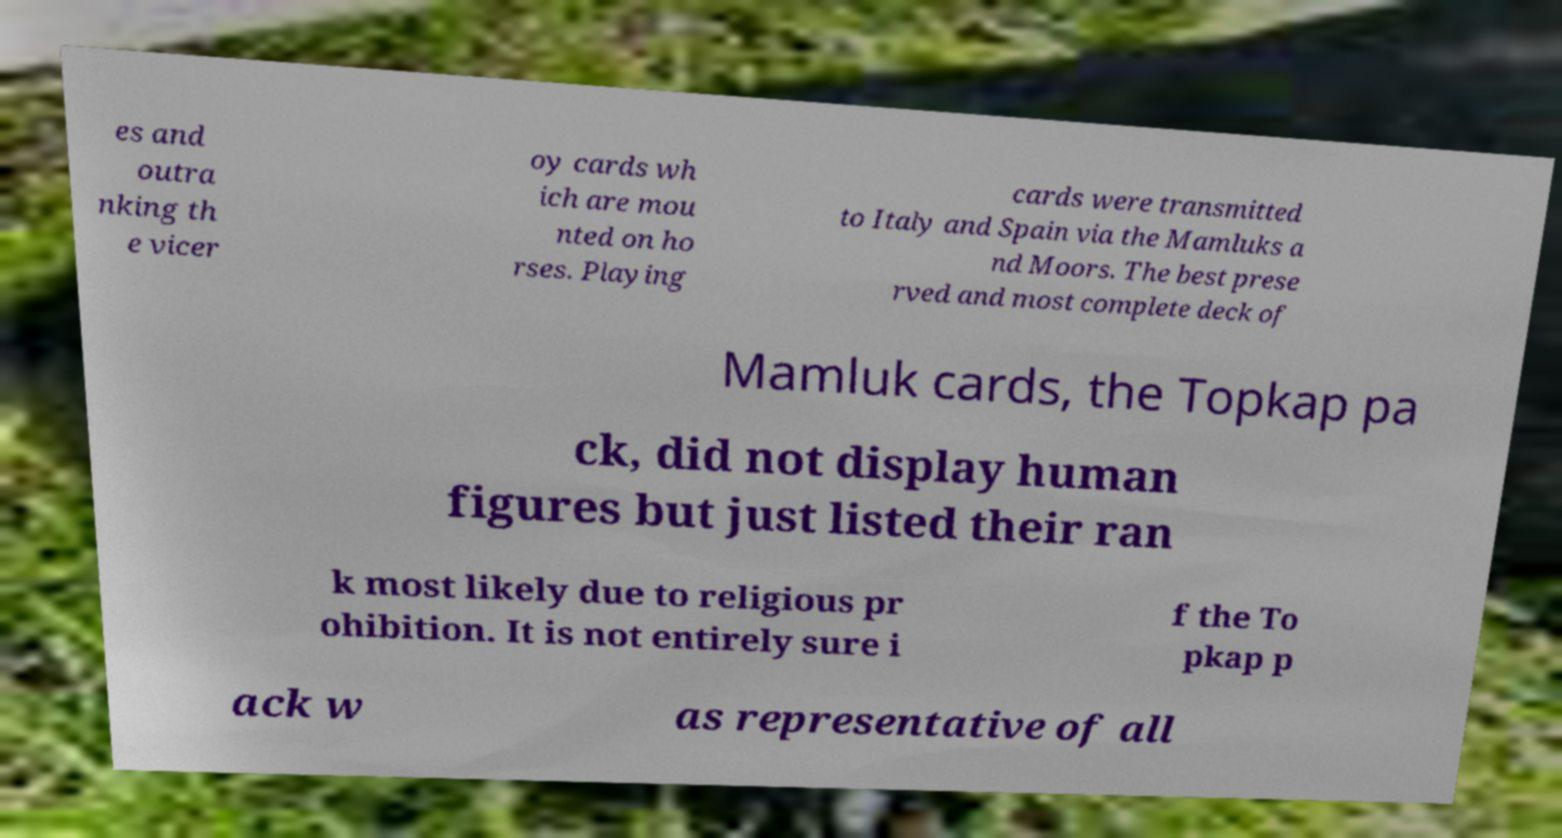Could you assist in decoding the text presented in this image and type it out clearly? es and outra nking th e vicer oy cards wh ich are mou nted on ho rses. Playing cards were transmitted to Italy and Spain via the Mamluks a nd Moors. The best prese rved and most complete deck of Mamluk cards, the Topkap pa ck, did not display human figures but just listed their ran k most likely due to religious pr ohibition. It is not entirely sure i f the To pkap p ack w as representative of all 